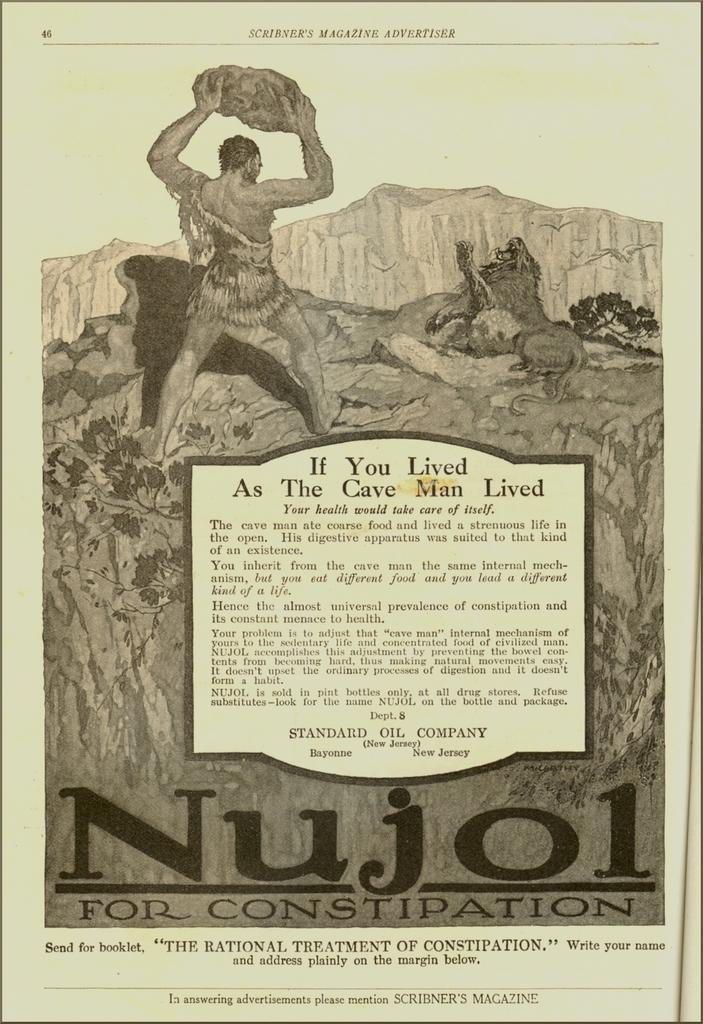Please provide a concise description of this image. In this image we can see a poster. On this poster we can see something is written on it. Here we can see picture of a person and an animal. 